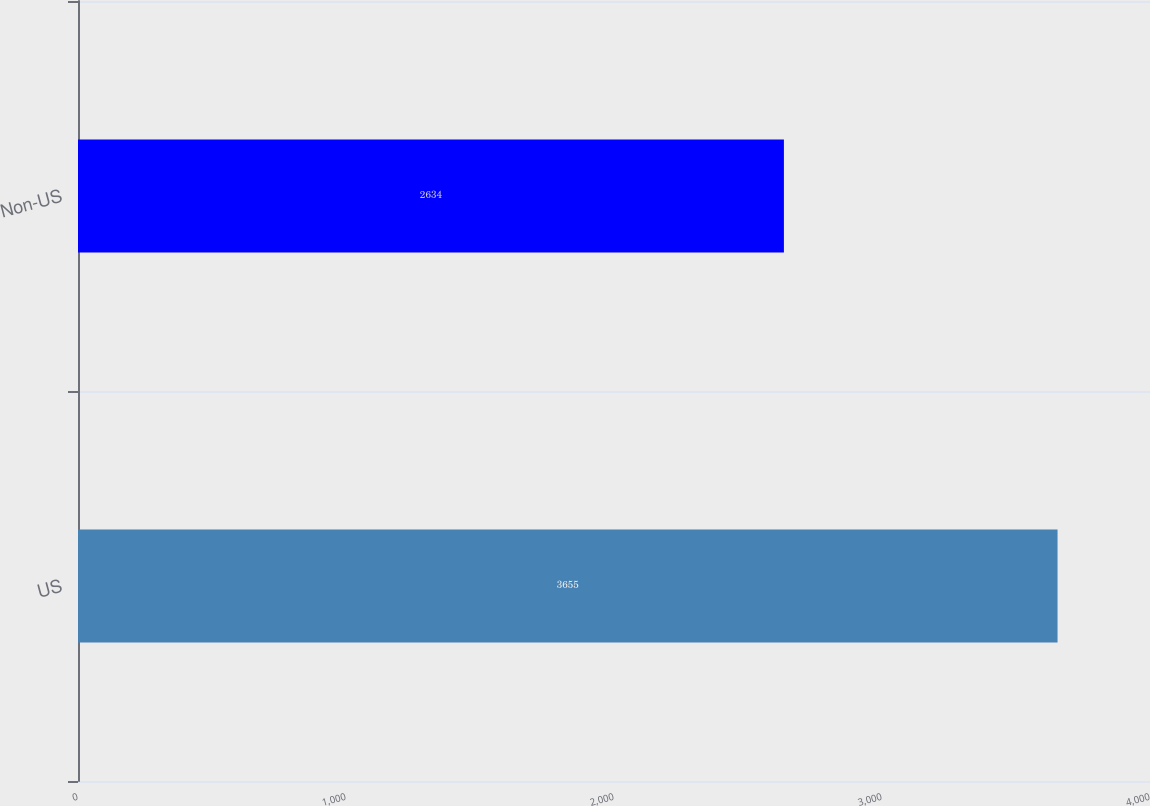Convert chart to OTSL. <chart><loc_0><loc_0><loc_500><loc_500><bar_chart><fcel>US<fcel>Non-US<nl><fcel>3655<fcel>2634<nl></chart> 